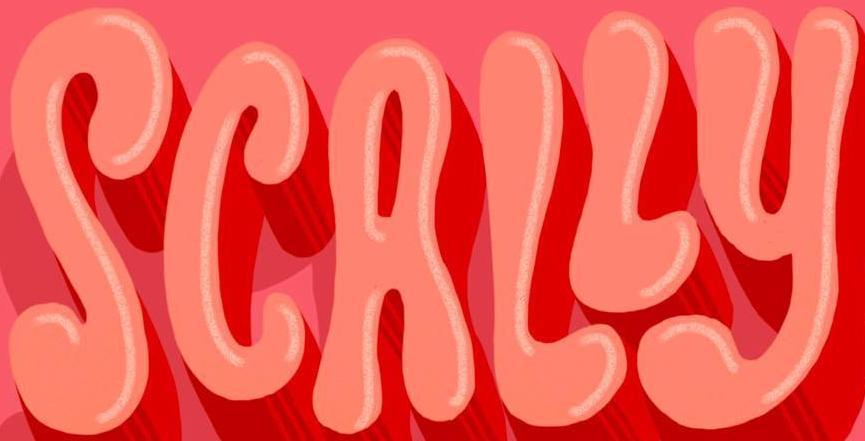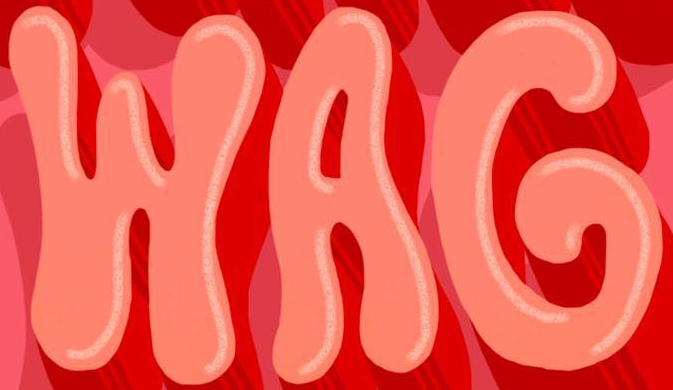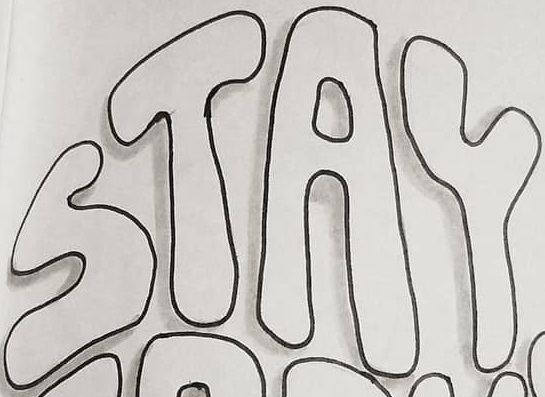Transcribe the words shown in these images in order, separated by a semicolon. SCALLY; WAG; STAY 